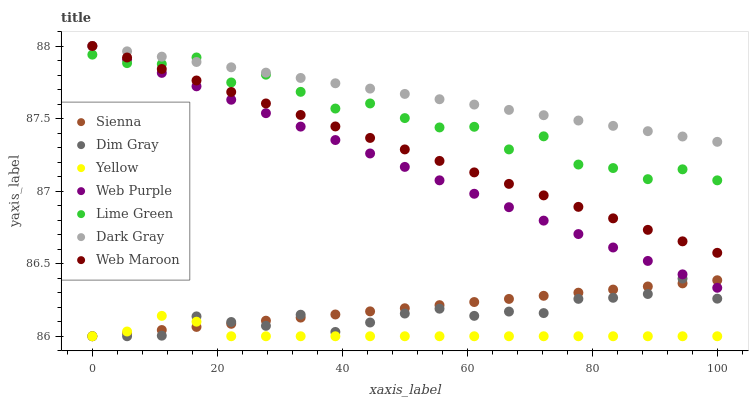Does Yellow have the minimum area under the curve?
Answer yes or no. Yes. Does Dark Gray have the maximum area under the curve?
Answer yes or no. Yes. Does Dim Gray have the minimum area under the curve?
Answer yes or no. No. Does Dim Gray have the maximum area under the curve?
Answer yes or no. No. Is Sienna the smoothest?
Answer yes or no. Yes. Is Lime Green the roughest?
Answer yes or no. Yes. Is Dim Gray the smoothest?
Answer yes or no. No. Is Dim Gray the roughest?
Answer yes or no. No. Does Dim Gray have the lowest value?
Answer yes or no. Yes. Does Web Maroon have the lowest value?
Answer yes or no. No. Does Web Purple have the highest value?
Answer yes or no. Yes. Does Dim Gray have the highest value?
Answer yes or no. No. Is Dim Gray less than Dark Gray?
Answer yes or no. Yes. Is Lime Green greater than Dim Gray?
Answer yes or no. Yes. Does Web Maroon intersect Web Purple?
Answer yes or no. Yes. Is Web Maroon less than Web Purple?
Answer yes or no. No. Is Web Maroon greater than Web Purple?
Answer yes or no. No. Does Dim Gray intersect Dark Gray?
Answer yes or no. No. 